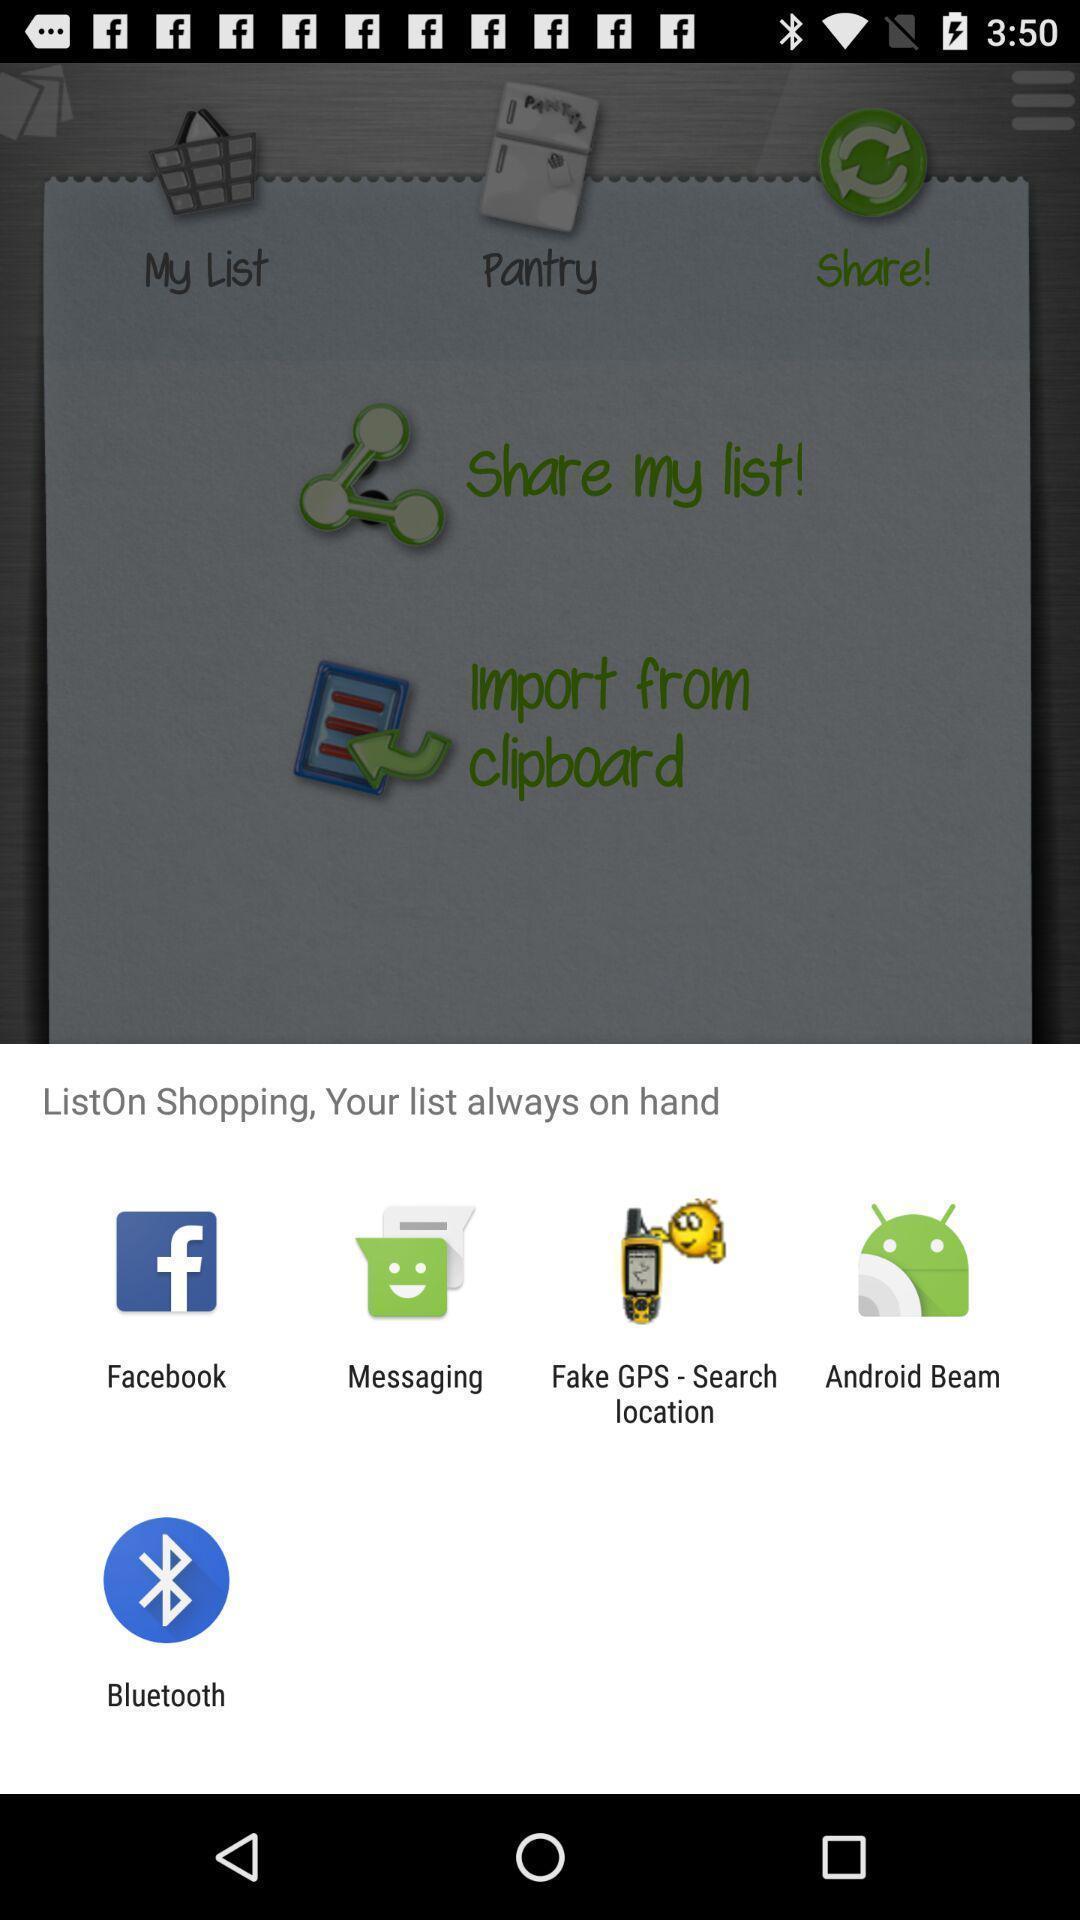Provide a textual representation of this image. Popup showing different apps to shopping. 